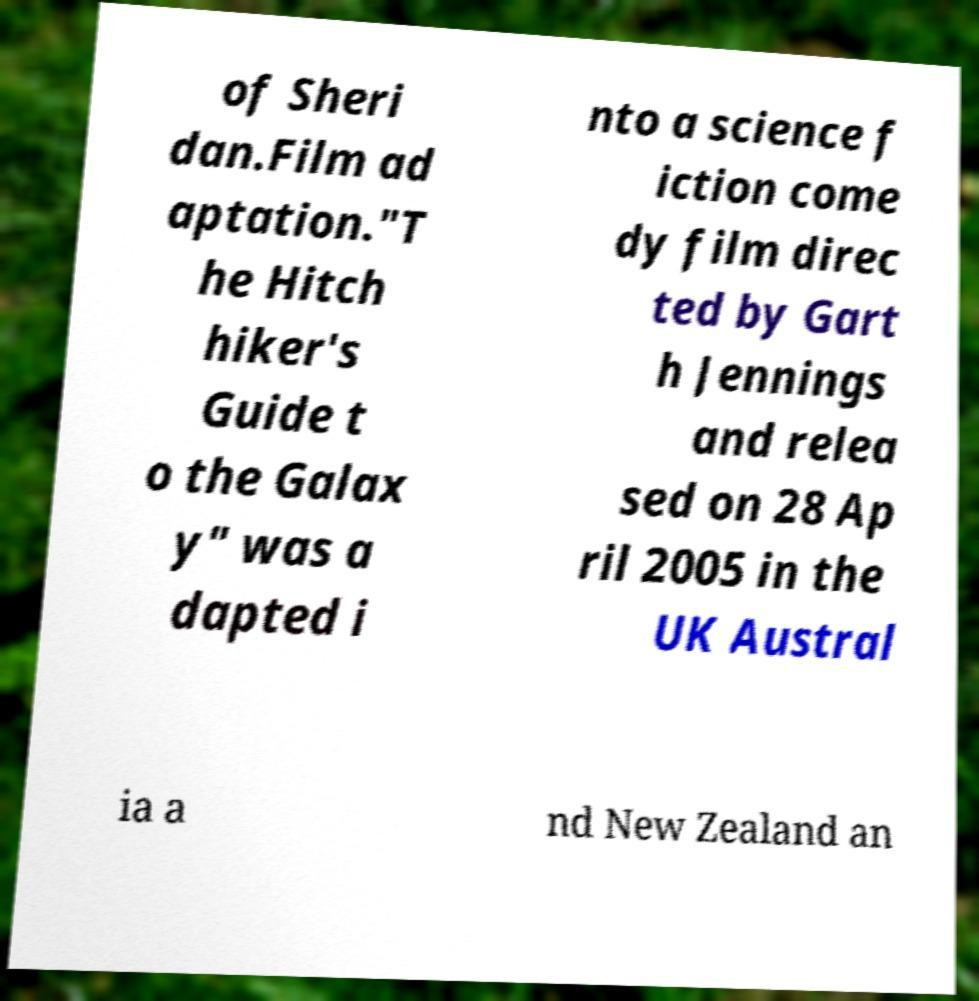Please read and relay the text visible in this image. What does it say? of Sheri dan.Film ad aptation."T he Hitch hiker's Guide t o the Galax y" was a dapted i nto a science f iction come dy film direc ted by Gart h Jennings and relea sed on 28 Ap ril 2005 in the UK Austral ia a nd New Zealand an 